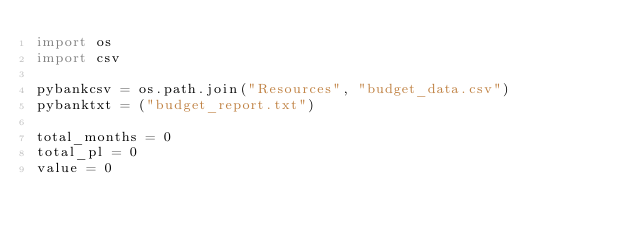Convert code to text. <code><loc_0><loc_0><loc_500><loc_500><_Python_>import os
import csv

pybankcsv = os.path.join("Resources", "budget_data.csv")
pybanktxt = ("budget_report.txt")

total_months = 0
total_pl = 0
value = 0</code> 